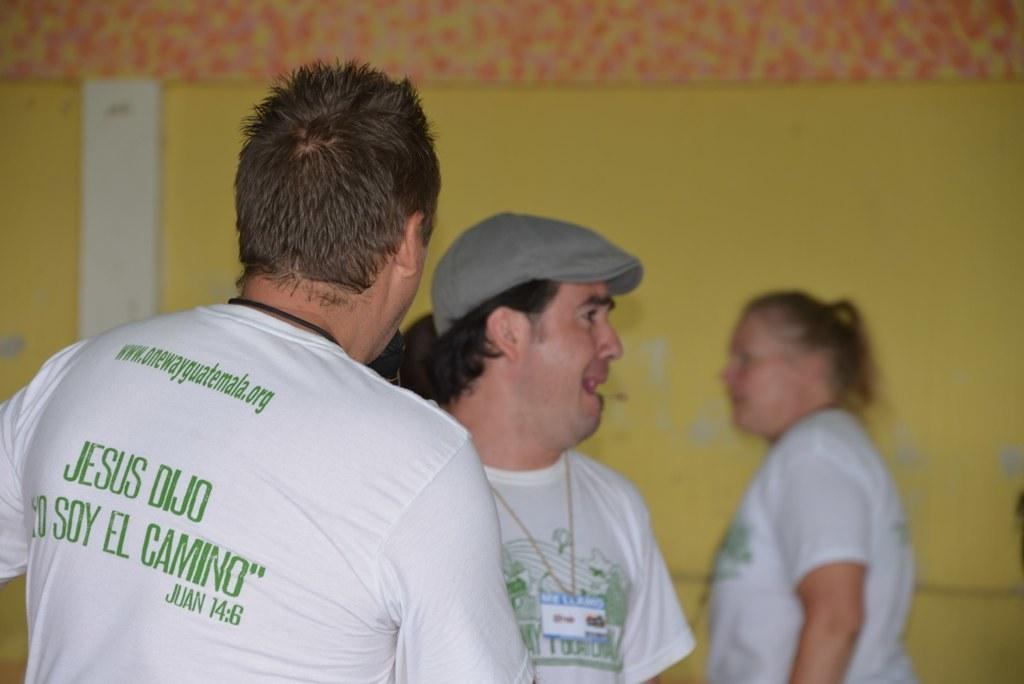In one or two sentences, can you explain what this image depicts? This is an inside view. On the left side, I can see two men wearing white color t-shirts. On the t-shirts I can see some text. One man is crying by looking at the right side. In the background, I can see a woman is also wearing a white color t-shirt facing towards the left side. In the background, I can see the wall. 